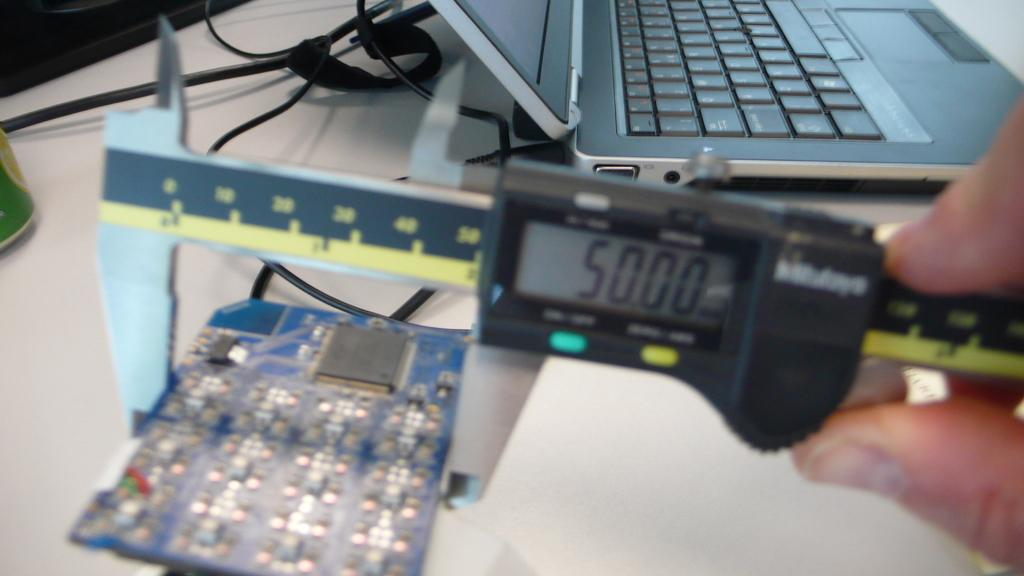<image>
Give a short and clear explanation of the subsequent image. a man holding what looks like a digital tape measure that says 50.00 on it 